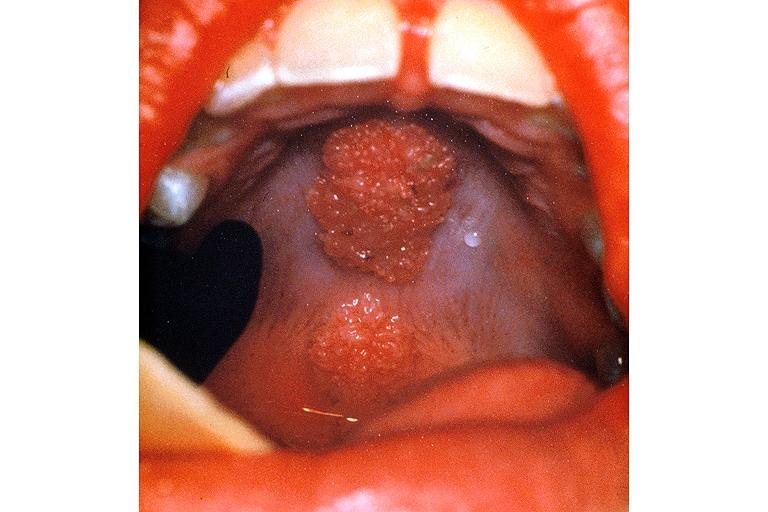s granuloma present?
Answer the question using a single word or phrase. No 